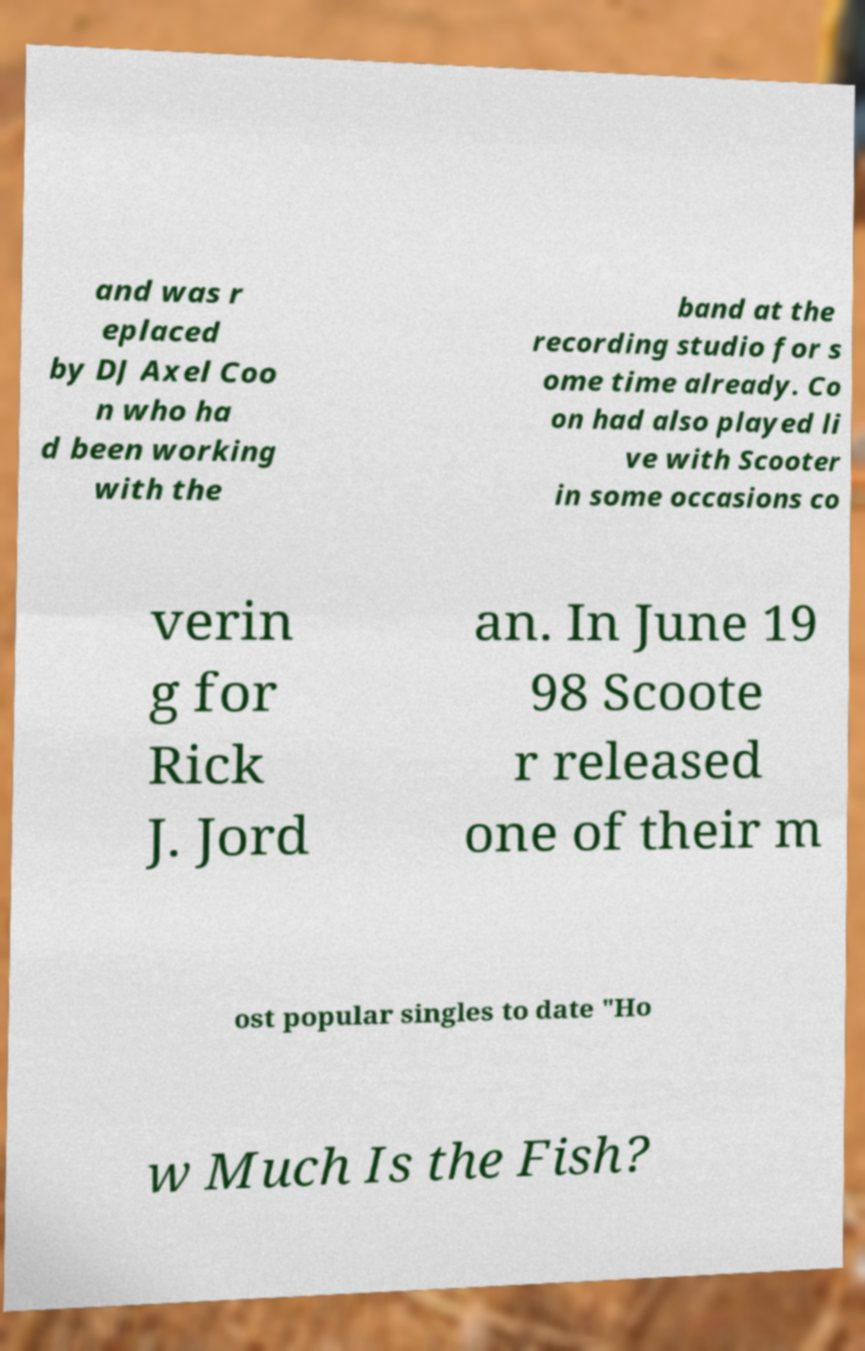There's text embedded in this image that I need extracted. Can you transcribe it verbatim? and was r eplaced by DJ Axel Coo n who ha d been working with the band at the recording studio for s ome time already. Co on had also played li ve with Scooter in some occasions co verin g for Rick J. Jord an. In June 19 98 Scoote r released one of their m ost popular singles to date "Ho w Much Is the Fish? 